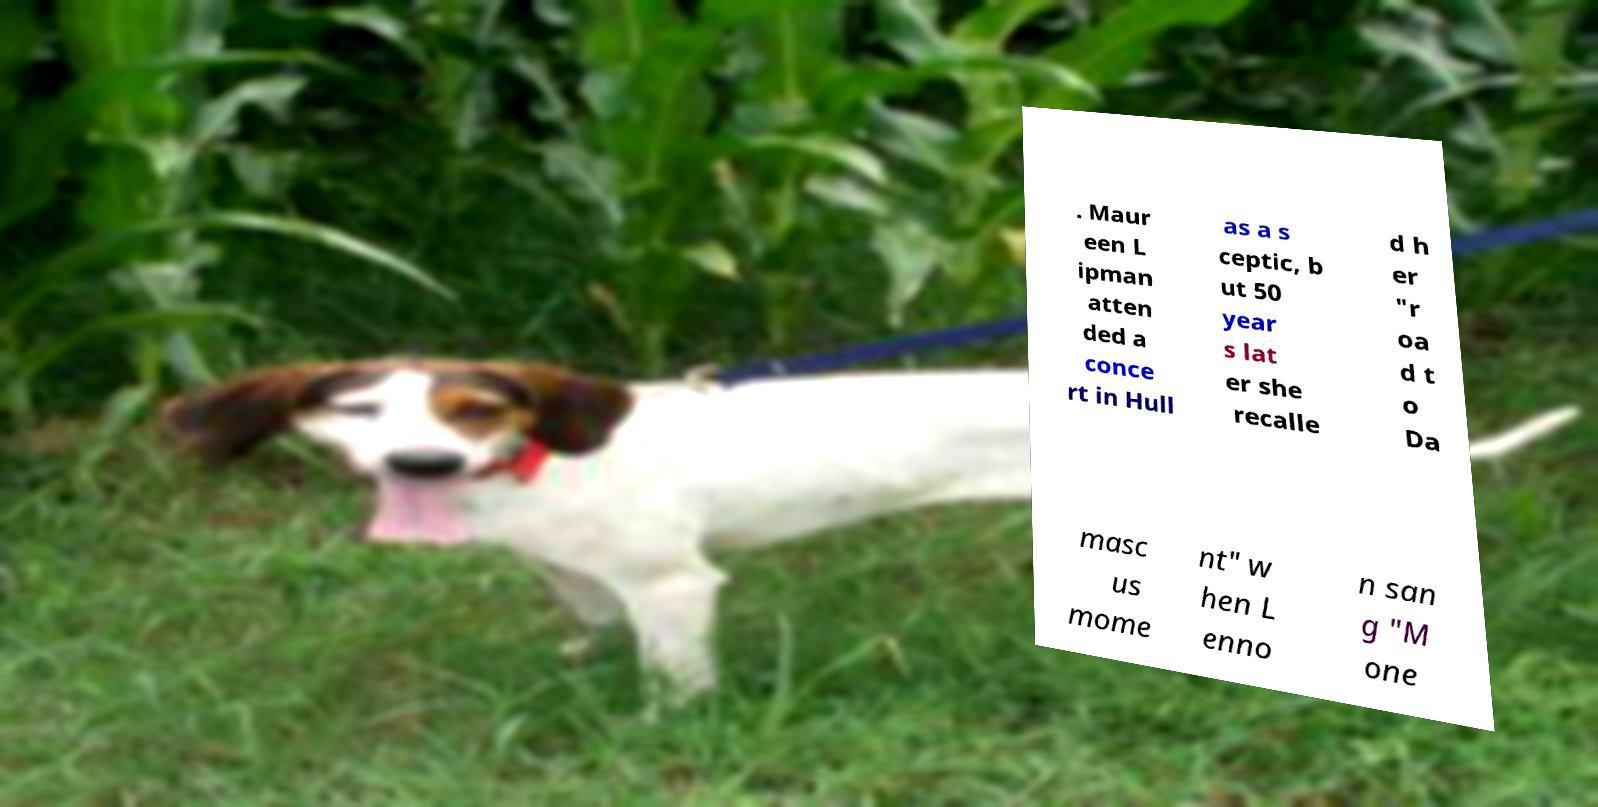Please identify and transcribe the text found in this image. . Maur een L ipman atten ded a conce rt in Hull as a s ceptic, b ut 50 year s lat er she recalle d h er "r oa d t o Da masc us mome nt" w hen L enno n san g "M one 